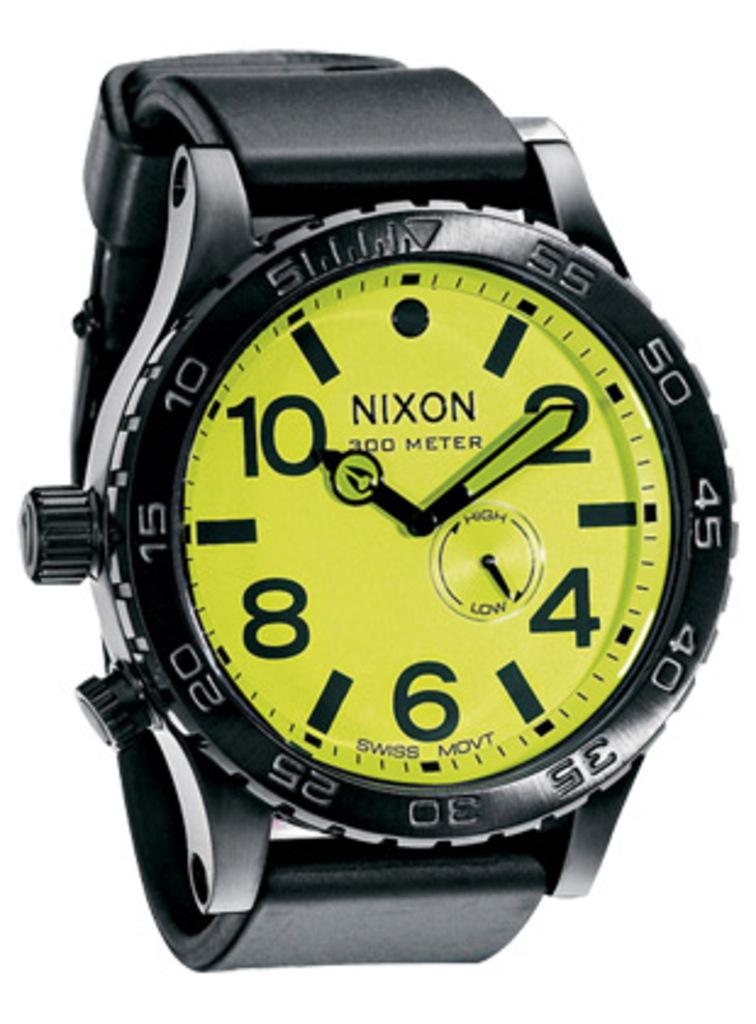<image>
Give a short and clear explanation of the subsequent image. A Nixon 300 Meter Swiss Movt watch shows the time to be 10:10. 